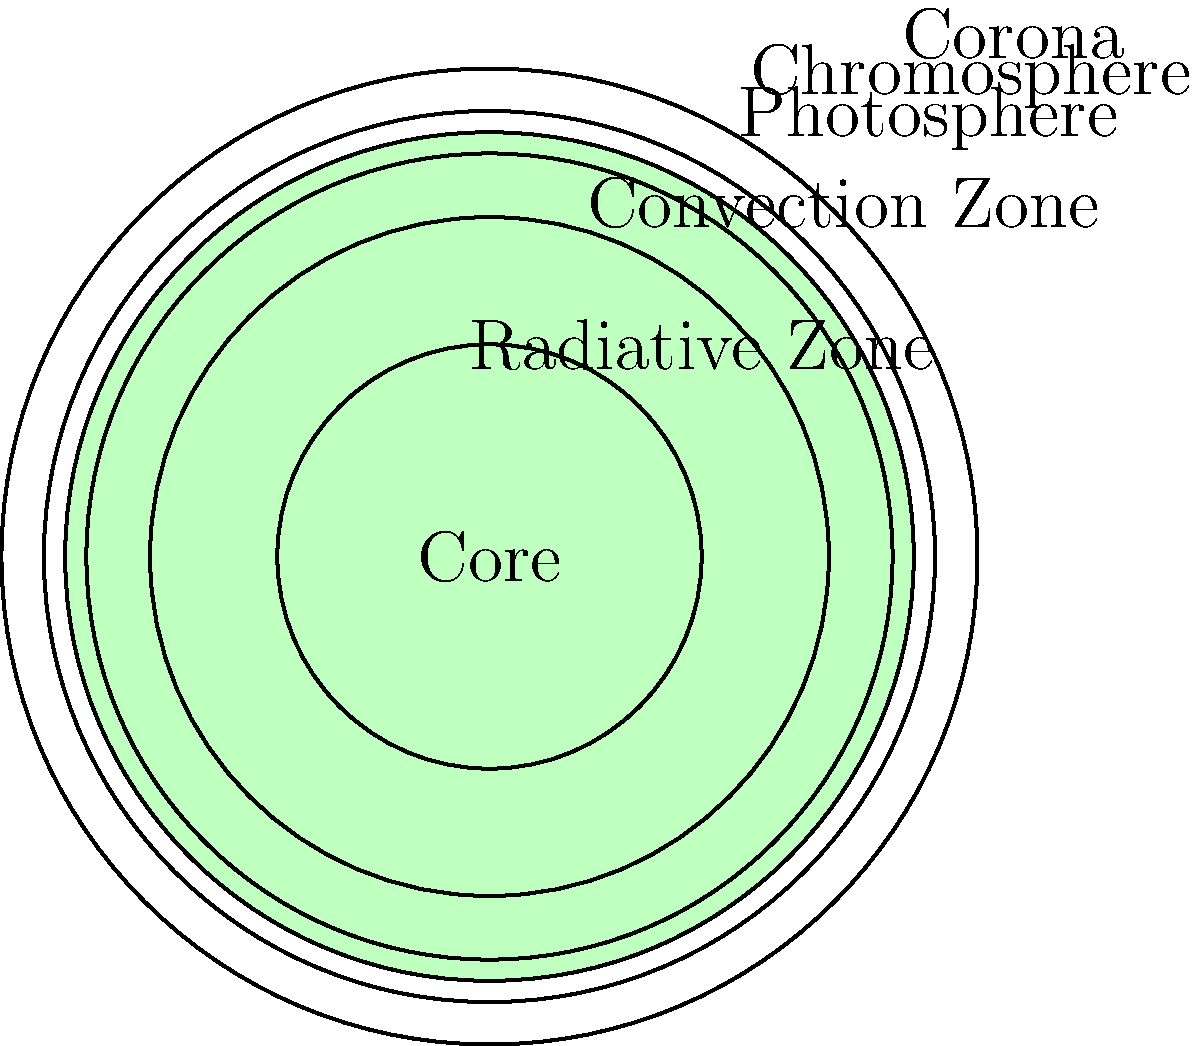As someone who's familiar with contraception options, you might appreciate the importance of understanding layers and protection. In the context of the Sun, which layer is responsible for the visible light we see, and what is its approximate temperature? Let's break this down step-by-step:

1. The Sun has several layers, each with distinct characteristics:
   - Core: The innermost layer, where nuclear fusion occurs
   - Radiative Zone: Where energy is transferred by radiation
   - Convection Zone: Where energy is transferred by convection
   - Photosphere: The visible "surface" of the Sun
   - Chromosphere: A thin layer above the photosphere
   - Corona: The outermost layer of the Sun's atmosphere

2. The layer responsible for the visible light we see is the photosphere. This is analogous to how the outer layer of a contraceptive pill is what we see and interact with.

3. The photosphere is often referred to as the Sun's "surface" because it's the layer we can see with our naked eyes, much like how the outer layer of a contraceptive device is what we can see and feel.

4. The temperature of the photosphere is not uniform, but it has an average temperature of about 5,800 Kelvin (K) or approximately 5,500°C (9,932°F).

5. This temperature is crucial for the Sun's visible light emission, just as the chemical composition of a contraceptive is crucial for its effectiveness.
Answer: Photosphere, approximately 5,800 K 